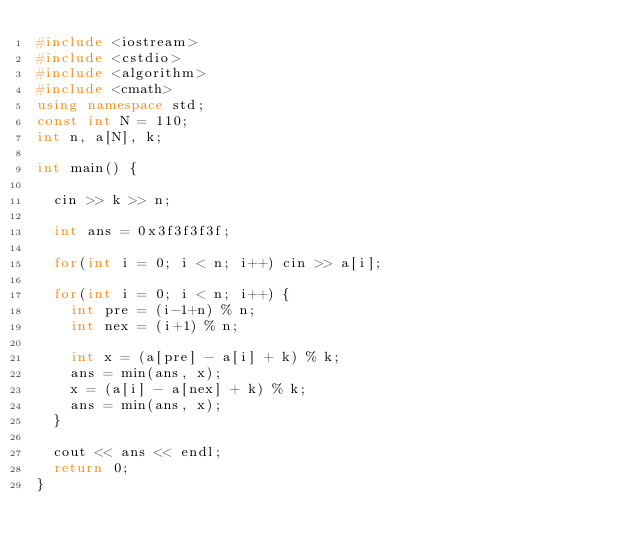Convert code to text. <code><loc_0><loc_0><loc_500><loc_500><_C++_>#include <iostream>
#include <cstdio>
#include <algorithm>
#include <cmath>
using namespace std;
const int N = 110;
int n, a[N], k;

int main() {
	
	cin >> k >> n;
	
	int ans = 0x3f3f3f3f;
	
	for(int i = 0; i < n; i++) cin >> a[i];
	
	for(int i = 0; i < n; i++) {
		int pre = (i-1+n) % n;
		int nex = (i+1) % n;
		
		int x = (a[pre] - a[i] + k) % k;
		ans = min(ans, x);
		x = (a[i] - a[nex] + k) % k;
		ans = min(ans, x);
	}
	
	cout << ans << endl;
	return 0;	
} </code> 